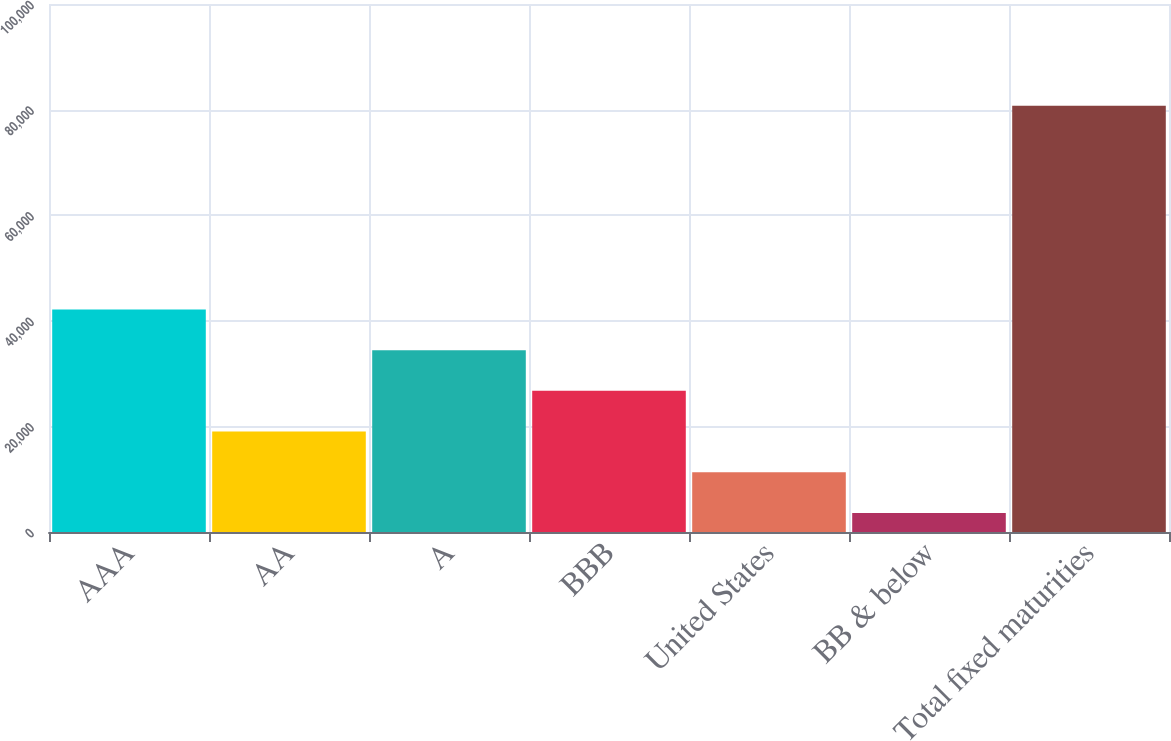Convert chart. <chart><loc_0><loc_0><loc_500><loc_500><bar_chart><fcel>AAA<fcel>AA<fcel>A<fcel>BBB<fcel>United States<fcel>BB & below<fcel>Total fixed maturities<nl><fcel>42159<fcel>19020<fcel>34446<fcel>26733<fcel>11307<fcel>3594<fcel>80724<nl></chart> 